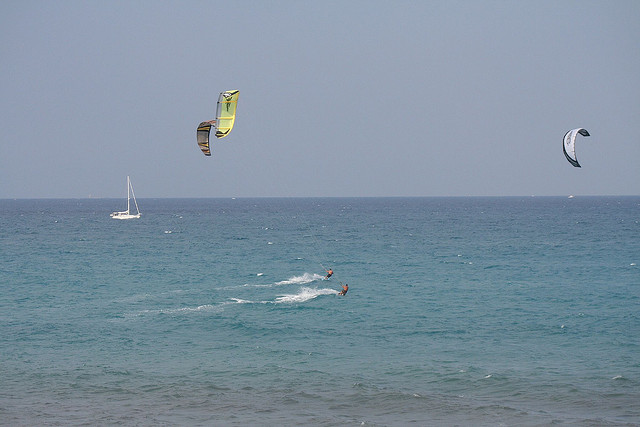Is there any evidence in the image of wind direction or strength? The direction and curvature of the parasails indicate the wind is coming from the left side of the image. The tautness and elevated position of the parasails suggest a strong and consistent wind, which is ideal for kite surfing. 